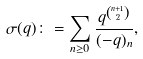Convert formula to latex. <formula><loc_0><loc_0><loc_500><loc_500>\sigma ( q ) \colon = \sum _ { n \geq 0 } \frac { q ^ { \binom { n + 1 } { 2 } } } { ( - q ) _ { n } } ,</formula> 